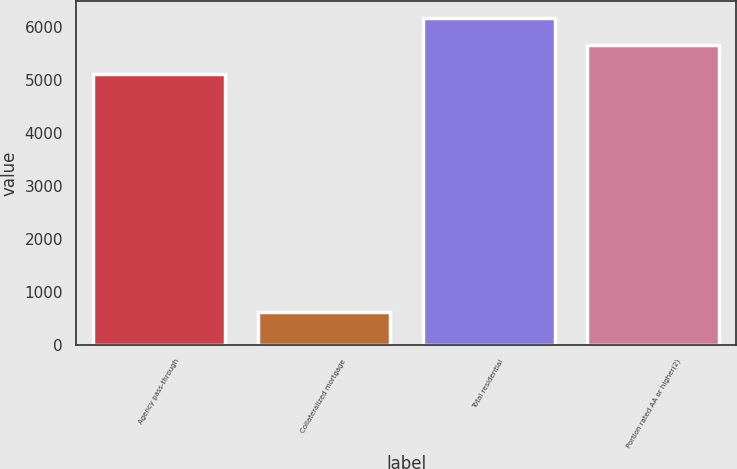<chart> <loc_0><loc_0><loc_500><loc_500><bar_chart><fcel>Agency pass-through<fcel>Collateralized mortgage<fcel>Total residential<fcel>Portion rated AA or higher(2)<nl><fcel>5118<fcel>629<fcel>6183.8<fcel>5672<nl></chart> 